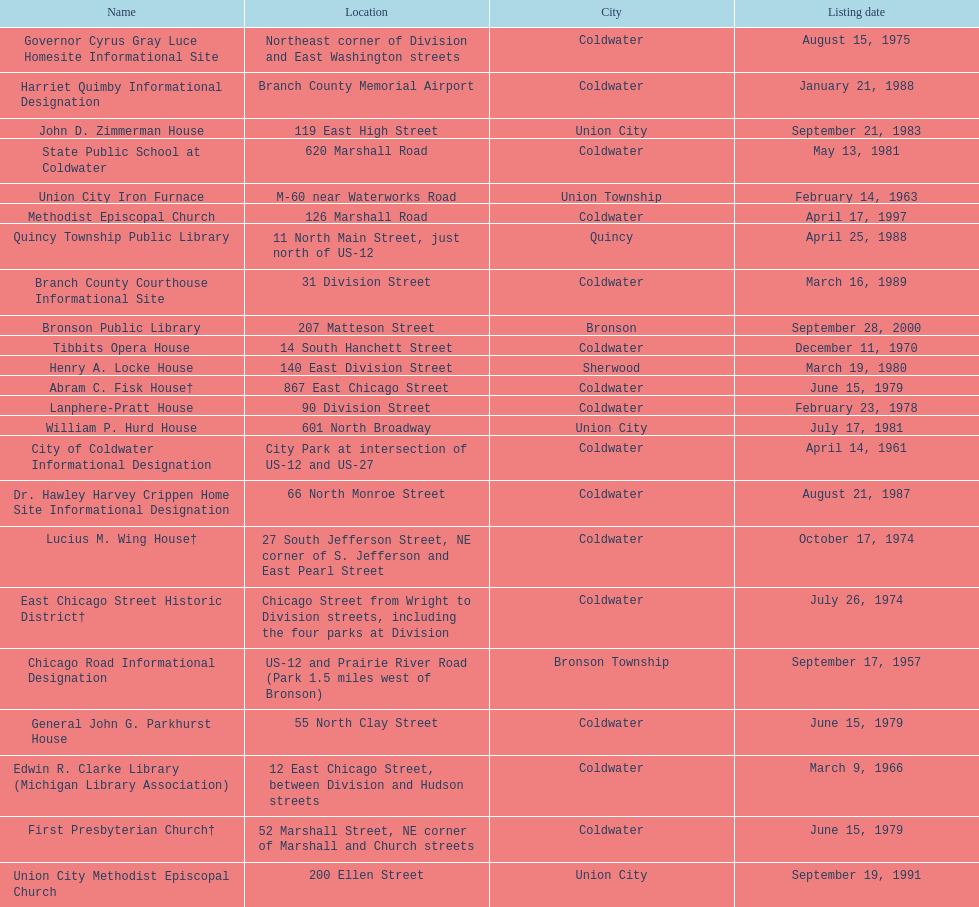How many historic sites were listed before 1965? 3. 